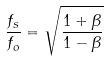<formula> <loc_0><loc_0><loc_500><loc_500>\frac { f _ { s } } { f _ { o } } = \sqrt { \frac { 1 + \beta } { 1 - \beta } }</formula> 